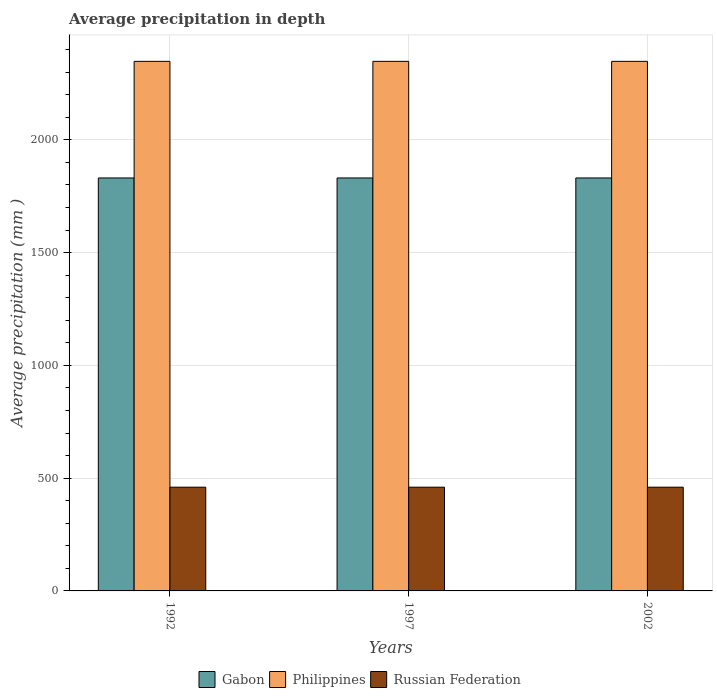How many different coloured bars are there?
Your response must be concise. 3. How many groups of bars are there?
Your answer should be very brief. 3. Are the number of bars on each tick of the X-axis equal?
Provide a short and direct response. Yes. How many bars are there on the 3rd tick from the left?
Your answer should be compact. 3. What is the label of the 1st group of bars from the left?
Give a very brief answer. 1992. In how many cases, is the number of bars for a given year not equal to the number of legend labels?
Your response must be concise. 0. What is the average precipitation in Philippines in 1992?
Offer a terse response. 2348. Across all years, what is the maximum average precipitation in Philippines?
Offer a very short reply. 2348. Across all years, what is the minimum average precipitation in Gabon?
Your response must be concise. 1831. What is the total average precipitation in Philippines in the graph?
Make the answer very short. 7044. What is the difference between the average precipitation in Gabon in 1997 and that in 2002?
Ensure brevity in your answer.  0. What is the difference between the average precipitation in Philippines in 1992 and the average precipitation in Russian Federation in 1997?
Make the answer very short. 1888. What is the average average precipitation in Russian Federation per year?
Keep it short and to the point. 460. In the year 1992, what is the difference between the average precipitation in Philippines and average precipitation in Russian Federation?
Make the answer very short. 1888. What is the ratio of the average precipitation in Philippines in 1997 to that in 2002?
Provide a succinct answer. 1. Is the difference between the average precipitation in Philippines in 1992 and 2002 greater than the difference between the average precipitation in Russian Federation in 1992 and 2002?
Provide a succinct answer. No. In how many years, is the average precipitation in Russian Federation greater than the average average precipitation in Russian Federation taken over all years?
Give a very brief answer. 0. Is the sum of the average precipitation in Russian Federation in 1992 and 2002 greater than the maximum average precipitation in Gabon across all years?
Provide a succinct answer. No. What does the 3rd bar from the left in 1997 represents?
Make the answer very short. Russian Federation. Is it the case that in every year, the sum of the average precipitation in Gabon and average precipitation in Philippines is greater than the average precipitation in Russian Federation?
Give a very brief answer. Yes. How many bars are there?
Your response must be concise. 9. Are all the bars in the graph horizontal?
Offer a very short reply. No. How many years are there in the graph?
Provide a short and direct response. 3. Are the values on the major ticks of Y-axis written in scientific E-notation?
Provide a succinct answer. No. Does the graph contain any zero values?
Offer a very short reply. No. How many legend labels are there?
Provide a short and direct response. 3. What is the title of the graph?
Keep it short and to the point. Average precipitation in depth. Does "Uruguay" appear as one of the legend labels in the graph?
Provide a succinct answer. No. What is the label or title of the X-axis?
Keep it short and to the point. Years. What is the label or title of the Y-axis?
Ensure brevity in your answer.  Average precipitation (mm ). What is the Average precipitation (mm ) in Gabon in 1992?
Offer a terse response. 1831. What is the Average precipitation (mm ) of Philippines in 1992?
Make the answer very short. 2348. What is the Average precipitation (mm ) of Russian Federation in 1992?
Your answer should be compact. 460. What is the Average precipitation (mm ) of Gabon in 1997?
Your answer should be compact. 1831. What is the Average precipitation (mm ) of Philippines in 1997?
Your response must be concise. 2348. What is the Average precipitation (mm ) in Russian Federation in 1997?
Provide a short and direct response. 460. What is the Average precipitation (mm ) in Gabon in 2002?
Your answer should be very brief. 1831. What is the Average precipitation (mm ) in Philippines in 2002?
Give a very brief answer. 2348. What is the Average precipitation (mm ) of Russian Federation in 2002?
Ensure brevity in your answer.  460. Across all years, what is the maximum Average precipitation (mm ) of Gabon?
Offer a very short reply. 1831. Across all years, what is the maximum Average precipitation (mm ) of Philippines?
Give a very brief answer. 2348. Across all years, what is the maximum Average precipitation (mm ) in Russian Federation?
Provide a short and direct response. 460. Across all years, what is the minimum Average precipitation (mm ) in Gabon?
Ensure brevity in your answer.  1831. Across all years, what is the minimum Average precipitation (mm ) in Philippines?
Your answer should be compact. 2348. Across all years, what is the minimum Average precipitation (mm ) of Russian Federation?
Ensure brevity in your answer.  460. What is the total Average precipitation (mm ) in Gabon in the graph?
Make the answer very short. 5493. What is the total Average precipitation (mm ) in Philippines in the graph?
Your answer should be compact. 7044. What is the total Average precipitation (mm ) of Russian Federation in the graph?
Keep it short and to the point. 1380. What is the difference between the Average precipitation (mm ) in Philippines in 1992 and that in 1997?
Your response must be concise. 0. What is the difference between the Average precipitation (mm ) in Russian Federation in 1992 and that in 1997?
Offer a terse response. 0. What is the difference between the Average precipitation (mm ) of Philippines in 1997 and that in 2002?
Provide a short and direct response. 0. What is the difference between the Average precipitation (mm ) in Russian Federation in 1997 and that in 2002?
Ensure brevity in your answer.  0. What is the difference between the Average precipitation (mm ) of Gabon in 1992 and the Average precipitation (mm ) of Philippines in 1997?
Ensure brevity in your answer.  -517. What is the difference between the Average precipitation (mm ) of Gabon in 1992 and the Average precipitation (mm ) of Russian Federation in 1997?
Provide a succinct answer. 1371. What is the difference between the Average precipitation (mm ) in Philippines in 1992 and the Average precipitation (mm ) in Russian Federation in 1997?
Provide a succinct answer. 1888. What is the difference between the Average precipitation (mm ) of Gabon in 1992 and the Average precipitation (mm ) of Philippines in 2002?
Your answer should be very brief. -517. What is the difference between the Average precipitation (mm ) of Gabon in 1992 and the Average precipitation (mm ) of Russian Federation in 2002?
Your answer should be very brief. 1371. What is the difference between the Average precipitation (mm ) in Philippines in 1992 and the Average precipitation (mm ) in Russian Federation in 2002?
Provide a succinct answer. 1888. What is the difference between the Average precipitation (mm ) in Gabon in 1997 and the Average precipitation (mm ) in Philippines in 2002?
Your answer should be very brief. -517. What is the difference between the Average precipitation (mm ) of Gabon in 1997 and the Average precipitation (mm ) of Russian Federation in 2002?
Give a very brief answer. 1371. What is the difference between the Average precipitation (mm ) of Philippines in 1997 and the Average precipitation (mm ) of Russian Federation in 2002?
Ensure brevity in your answer.  1888. What is the average Average precipitation (mm ) in Gabon per year?
Provide a short and direct response. 1831. What is the average Average precipitation (mm ) of Philippines per year?
Provide a succinct answer. 2348. What is the average Average precipitation (mm ) of Russian Federation per year?
Offer a terse response. 460. In the year 1992, what is the difference between the Average precipitation (mm ) of Gabon and Average precipitation (mm ) of Philippines?
Your response must be concise. -517. In the year 1992, what is the difference between the Average precipitation (mm ) of Gabon and Average precipitation (mm ) of Russian Federation?
Your response must be concise. 1371. In the year 1992, what is the difference between the Average precipitation (mm ) of Philippines and Average precipitation (mm ) of Russian Federation?
Offer a terse response. 1888. In the year 1997, what is the difference between the Average precipitation (mm ) of Gabon and Average precipitation (mm ) of Philippines?
Make the answer very short. -517. In the year 1997, what is the difference between the Average precipitation (mm ) of Gabon and Average precipitation (mm ) of Russian Federation?
Your answer should be compact. 1371. In the year 1997, what is the difference between the Average precipitation (mm ) in Philippines and Average precipitation (mm ) in Russian Federation?
Keep it short and to the point. 1888. In the year 2002, what is the difference between the Average precipitation (mm ) in Gabon and Average precipitation (mm ) in Philippines?
Provide a succinct answer. -517. In the year 2002, what is the difference between the Average precipitation (mm ) of Gabon and Average precipitation (mm ) of Russian Federation?
Offer a terse response. 1371. In the year 2002, what is the difference between the Average precipitation (mm ) in Philippines and Average precipitation (mm ) in Russian Federation?
Provide a short and direct response. 1888. What is the ratio of the Average precipitation (mm ) in Philippines in 1992 to that in 1997?
Offer a very short reply. 1. What is the ratio of the Average precipitation (mm ) in Russian Federation in 1992 to that in 1997?
Your response must be concise. 1. What is the ratio of the Average precipitation (mm ) in Gabon in 1992 to that in 2002?
Your answer should be very brief. 1. What is the ratio of the Average precipitation (mm ) of Philippines in 1992 to that in 2002?
Provide a short and direct response. 1. What is the ratio of the Average precipitation (mm ) in Russian Federation in 1992 to that in 2002?
Keep it short and to the point. 1. What is the ratio of the Average precipitation (mm ) of Gabon in 1997 to that in 2002?
Make the answer very short. 1. What is the ratio of the Average precipitation (mm ) in Russian Federation in 1997 to that in 2002?
Provide a short and direct response. 1. What is the difference between the highest and the second highest Average precipitation (mm ) of Philippines?
Ensure brevity in your answer.  0. What is the difference between the highest and the second highest Average precipitation (mm ) of Russian Federation?
Your answer should be very brief. 0. What is the difference between the highest and the lowest Average precipitation (mm ) in Gabon?
Provide a succinct answer. 0. What is the difference between the highest and the lowest Average precipitation (mm ) of Russian Federation?
Your answer should be very brief. 0. 